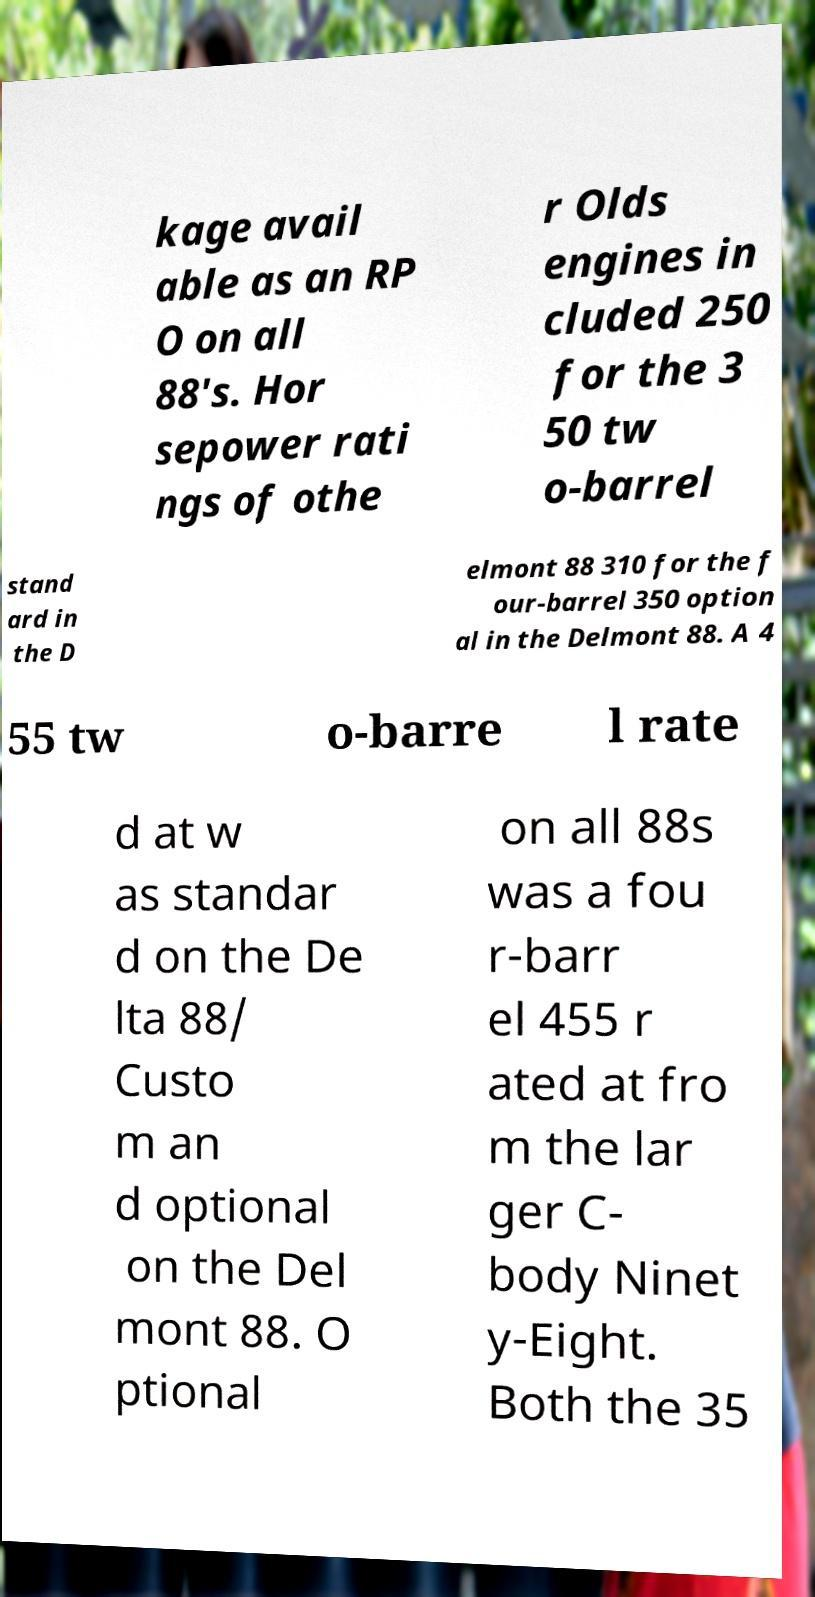Could you extract and type out the text from this image? kage avail able as an RP O on all 88's. Hor sepower rati ngs of othe r Olds engines in cluded 250 for the 3 50 tw o-barrel stand ard in the D elmont 88 310 for the f our-barrel 350 option al in the Delmont 88. A 4 55 tw o-barre l rate d at w as standar d on the De lta 88/ Custo m an d optional on the Del mont 88. O ptional on all 88s was a fou r-barr el 455 r ated at fro m the lar ger C- body Ninet y-Eight. Both the 35 